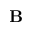Convert formula to latex. <formula><loc_0><loc_0><loc_500><loc_500>B</formula> 